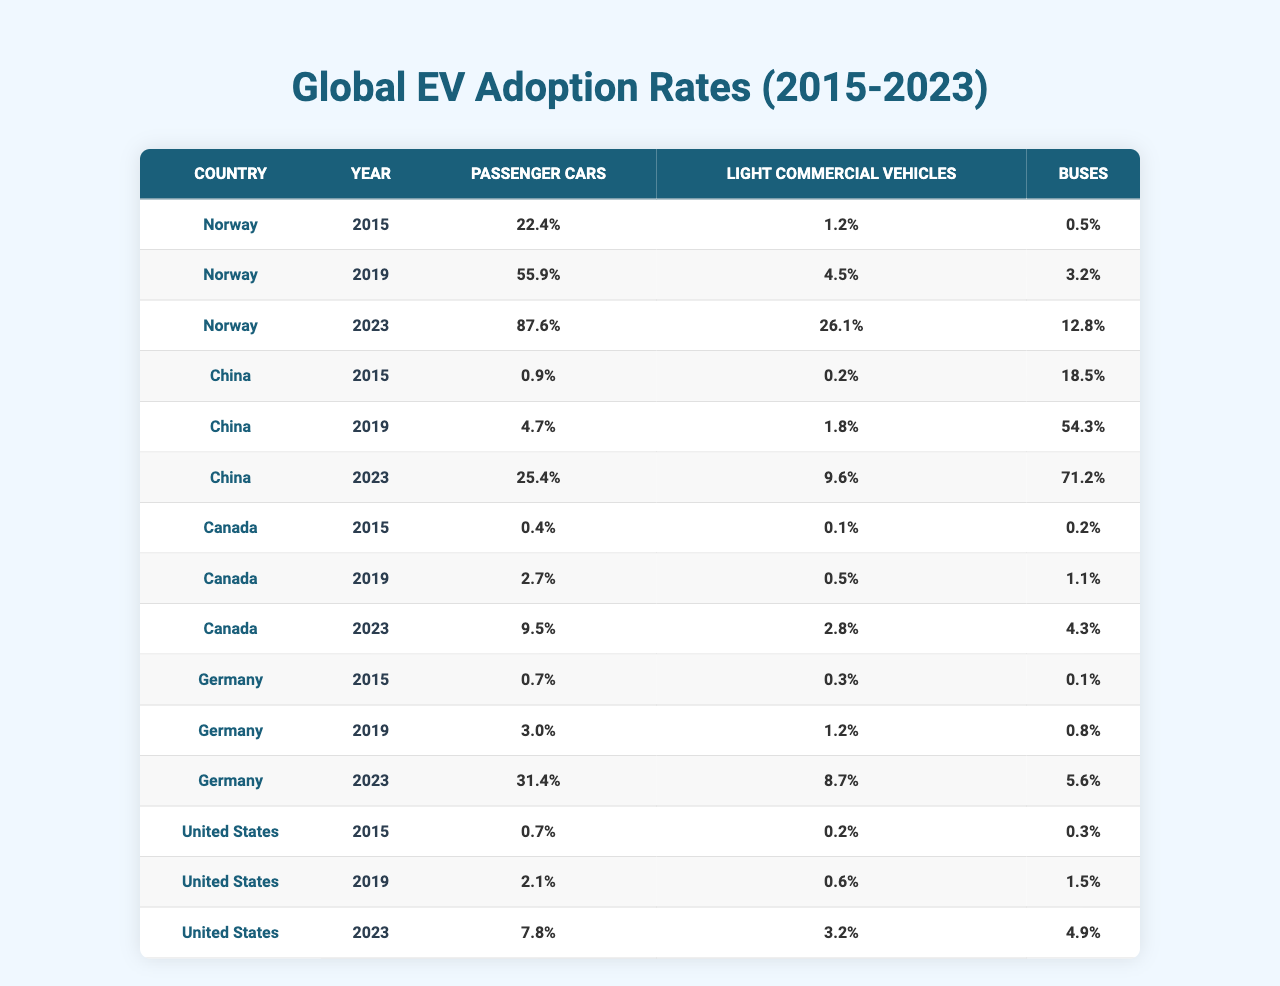What were the electric vehicle adoption rates for passenger cars in Norway in 2023? Referring to the table, Norway's adoption rate for passenger cars in 2023 is 87.6%.
Answer: 87.6% Which country had the highest adoption rate for buses in 2023? The rates show that China had the highest adoption rate for buses in 2023 at 71.2%.
Answer: China What is the average adoption rate for light commercial vehicles across all countries in 2019? Summing the adoption rates for light commercial vehicles in 2019: 4.5 (Norway) + 1.8 (China) + 0.5 (Canada) + 1.2 (Germany) + 0.6 (United States) = 8.6. There are 5 countries, so the average is 8.6 / 5 = 1.72%.
Answer: 1.72% Is the adoption rate for passenger cars in Canada higher than in the United States in 2023? Canada's adoption rate for passenger cars in 2023 is 9.5%, while the United States rate is 7.8%, making Canada's rate higher.
Answer: Yes What is the percentage increase in adoption rates for passenger cars in Germany from 2015 to 2023? The rate for passenger cars in Germany in 2015 was 0.7%, and in 2023 it was 31.4%. The increase is calculated as 31.4 - 0.7 = 30.7%.
Answer: 30.7% For which country did the adoption rate of light commercial vehicles show the most significant percentage increase between 2015 and 2023? In 2015, Norway had a rate of 1.2%, and in 2023 it increased to 26.1%, an increase of 24.9%. For China, it was 0.2% to 9.6%, an increase of 9.4%. Norway's increase is the most significant.
Answer: Norway What is the total percentage adoption for buses across all countries in 2023? The total adoption percentage for buses in 2023 is calculated as: 12.8 (Norway) + 71.2 (China) + 4.3 (Canada) + 5.6 (Germany) + 4.9 (United States) = 99.8%.
Answer: 99.8% Which country had the least adoption for light commercial vehicles in 2015? Referring to the table, Canada had the least adoption rate for light commercial vehicles in 2015 at 0.1%.
Answer: Canada Did Norway's adoption rates for passenger cars surpass 50% by 2019? Yes, Norway's adoption rate for passenger cars in 2019 was 55.9%, which is above 50%.
Answer: Yes What is the difference in electric vehicle adoption rates for buses between China in 2023 and Norway in 2023? For buses, China had a rate of 71.2% in 2023, while Norway had 12.8%, so the difference is 71.2 - 12.8 = 58.4%.
Answer: 58.4% 